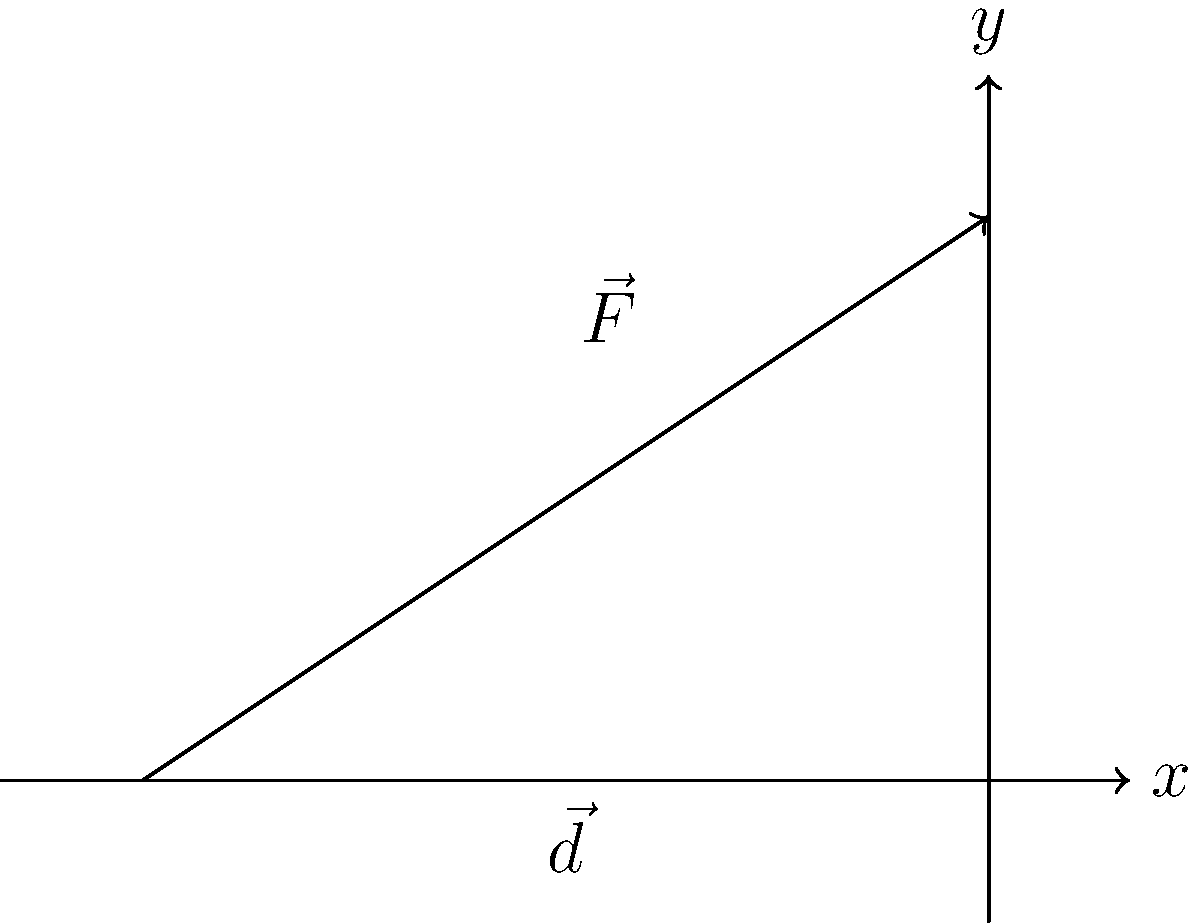For an upcoming church event, you need to move a heavy altar. The force $\vec{F} = \langle 150, 100 \rangle$ N is applied to move the altar along the displacement vector $\vec{d} = \langle 3, 0 \rangle$ m. Calculate the work done in moving the altar. To calculate the work done, we need to use the dot product of the force vector and the displacement vector. The formula for work is:

$W = \vec{F} \cdot \vec{d}$

Let's follow these steps:

1) We have:
   $\vec{F} = \langle 150, 100 \rangle$ N
   $\vec{d} = \langle 3, 0 \rangle$ m

2) The dot product is calculated as:
   $\vec{F} \cdot \vec{d} = (F_x \times d_x) + (F_y \times d_y)$

3) Substituting the values:
   $W = (150 \times 3) + (100 \times 0)$

4) Simplifying:
   $W = 450 + 0 = 450$

5) The unit of work is Newton-meters (Nm) or Joules (J).

Therefore, the work done in moving the altar is 450 J.
Answer: 450 J 